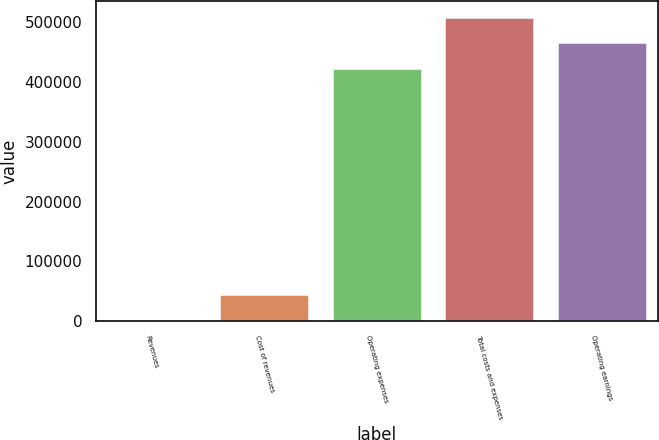<chart> <loc_0><loc_0><loc_500><loc_500><bar_chart><fcel>Revenues<fcel>Cost of revenues<fcel>Operating expenses<fcel>Total costs and expenses<fcel>Operating earnings<nl><fcel>3789<fcel>46261.9<fcel>423245<fcel>508191<fcel>465718<nl></chart> 